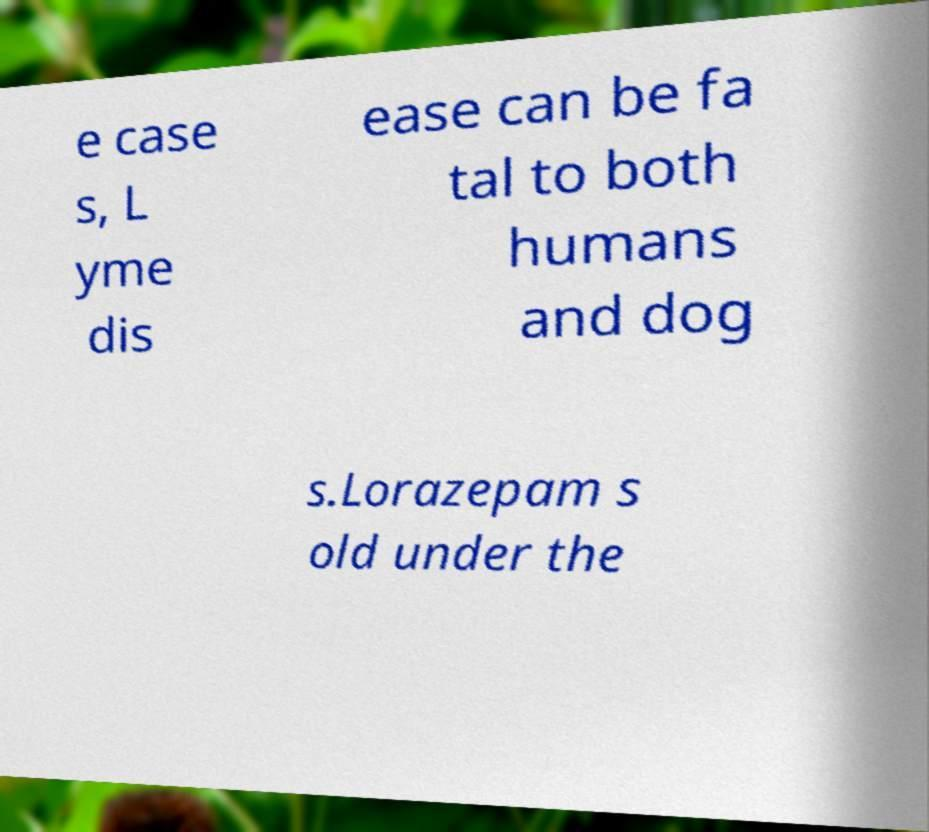For documentation purposes, I need the text within this image transcribed. Could you provide that? e case s, L yme dis ease can be fa tal to both humans and dog s.Lorazepam s old under the 